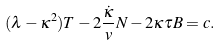Convert formula to latex. <formula><loc_0><loc_0><loc_500><loc_500>( \lambda - \kappa ^ { 2 } ) T - 2 \frac { \dot { \kappa } } { v } N - 2 \kappa \tau B = c .</formula> 